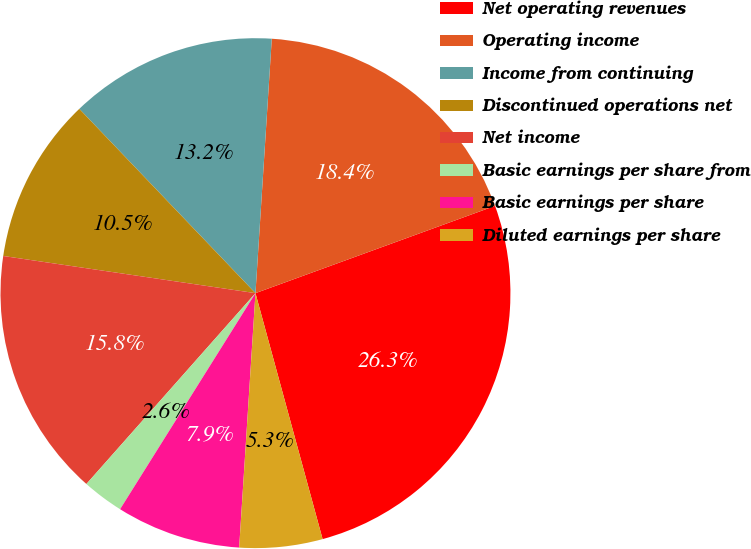Convert chart. <chart><loc_0><loc_0><loc_500><loc_500><pie_chart><fcel>Net operating revenues<fcel>Operating income<fcel>Income from continuing<fcel>Discontinued operations net<fcel>Net income<fcel>Basic earnings per share from<fcel>Basic earnings per share<fcel>Diluted earnings per share<nl><fcel>26.32%<fcel>18.42%<fcel>13.16%<fcel>10.53%<fcel>15.79%<fcel>2.63%<fcel>7.89%<fcel>5.26%<nl></chart> 